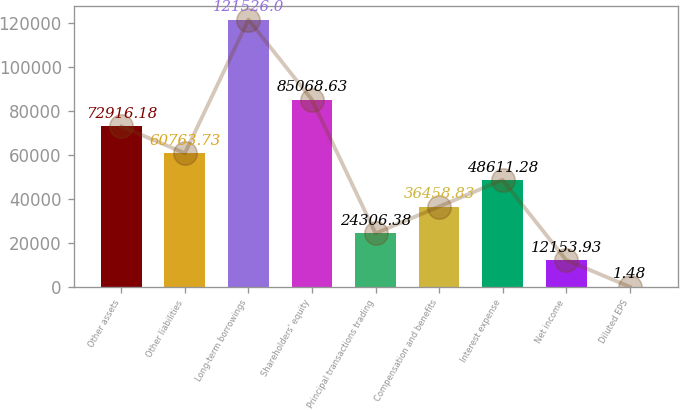Convert chart to OTSL. <chart><loc_0><loc_0><loc_500><loc_500><bar_chart><fcel>Other assets<fcel>Other liabilities<fcel>Long-term borrowings<fcel>Shareholders' equity<fcel>Principal transactions trading<fcel>Compensation and benefits<fcel>Interest expense<fcel>Net income<fcel>Diluted EPS<nl><fcel>72916.2<fcel>60763.7<fcel>121526<fcel>85068.6<fcel>24306.4<fcel>36458.8<fcel>48611.3<fcel>12153.9<fcel>1.48<nl></chart> 